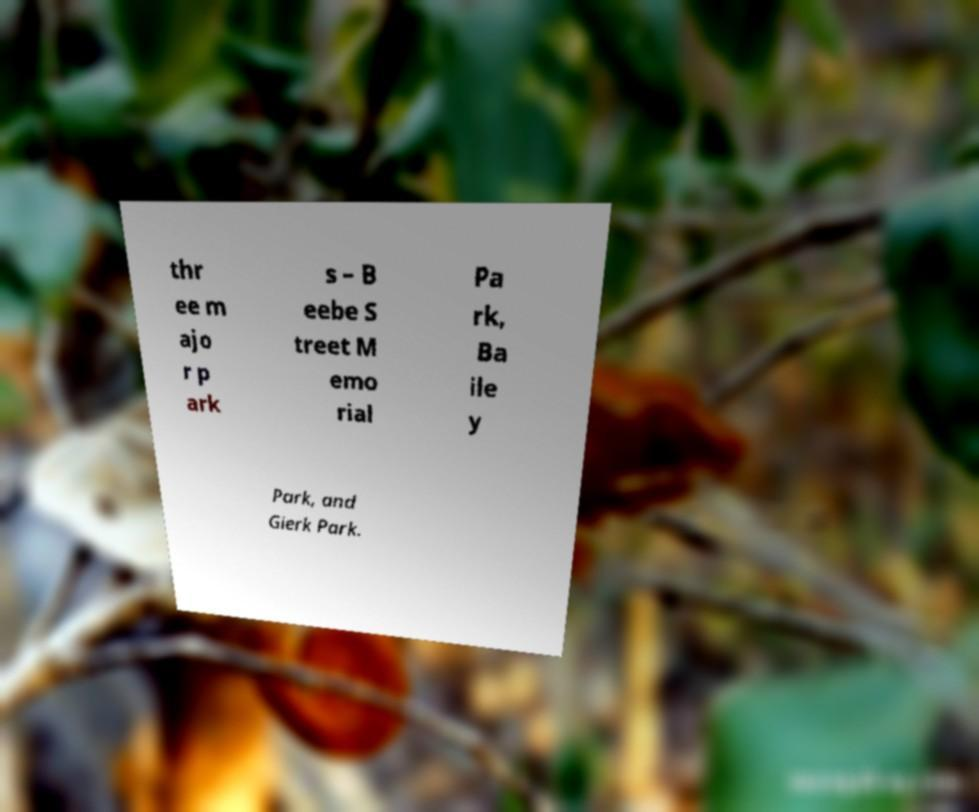Could you extract and type out the text from this image? thr ee m ajo r p ark s – B eebe S treet M emo rial Pa rk, Ba ile y Park, and Gierk Park. 